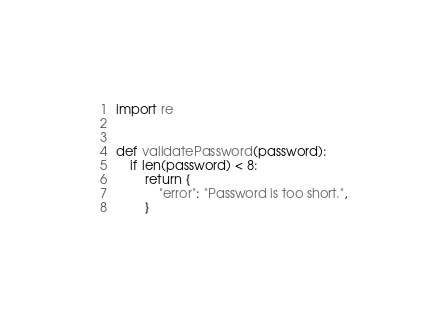Convert code to text. <code><loc_0><loc_0><loc_500><loc_500><_Python_>import re


def validatePassword(password):
    if len(password) < 8:
        return {
            "error": "Password is too short.",
        }
</code> 